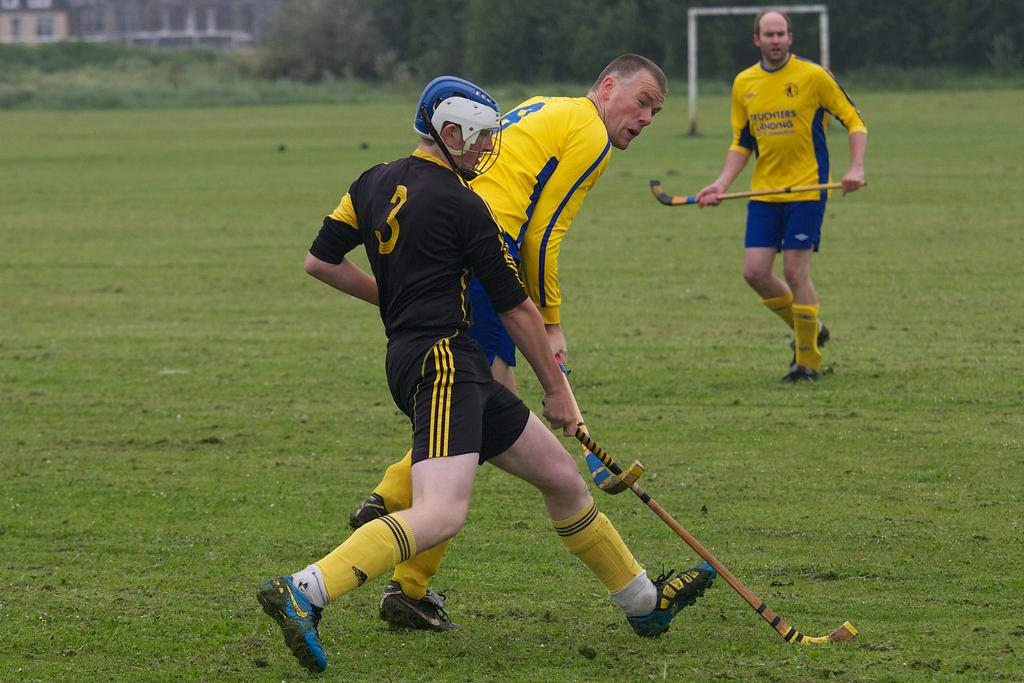Provide a one-sentence caption for the provided image. guy wearing black with #3 jersey  and two others with yellow and blue on field. 